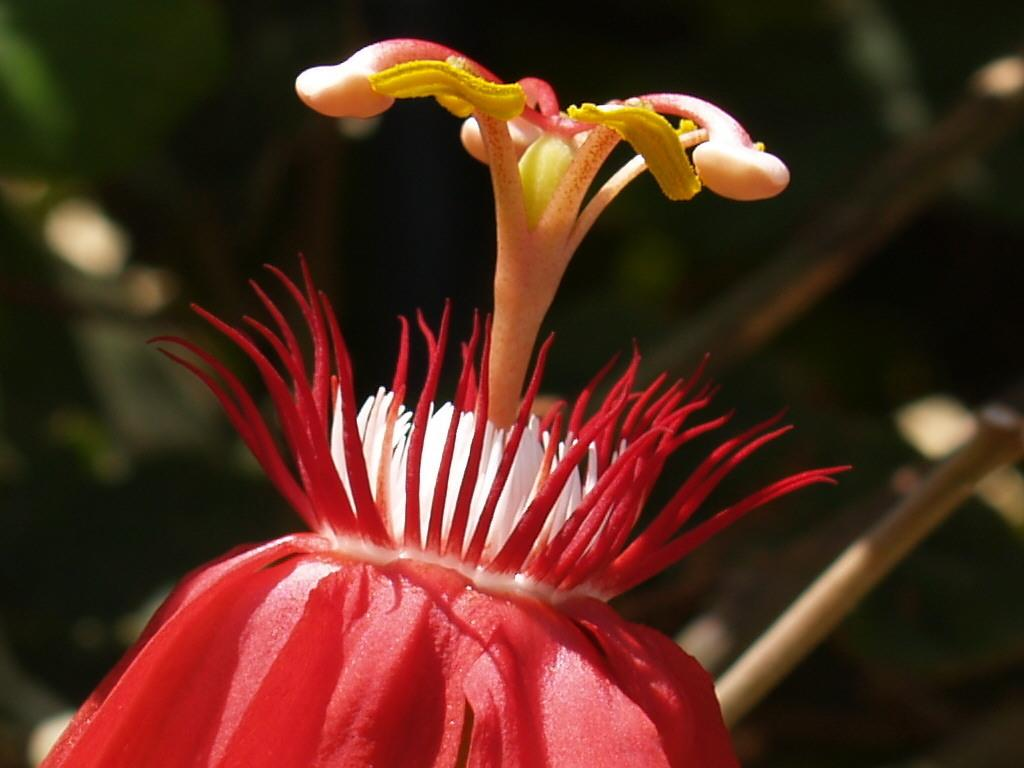What part of a flower is visible in the image? The image shows the inner part of a flower. What colors can be seen in the flower? The flower has yellow, white, and red colors. Can you see a crow perched on the flower in the image? No, there is no crow present in the image. What type of sock is wrapped around the stem of the flower in the image? There is no sock present in the image; it only shows the inner part of the flower. 